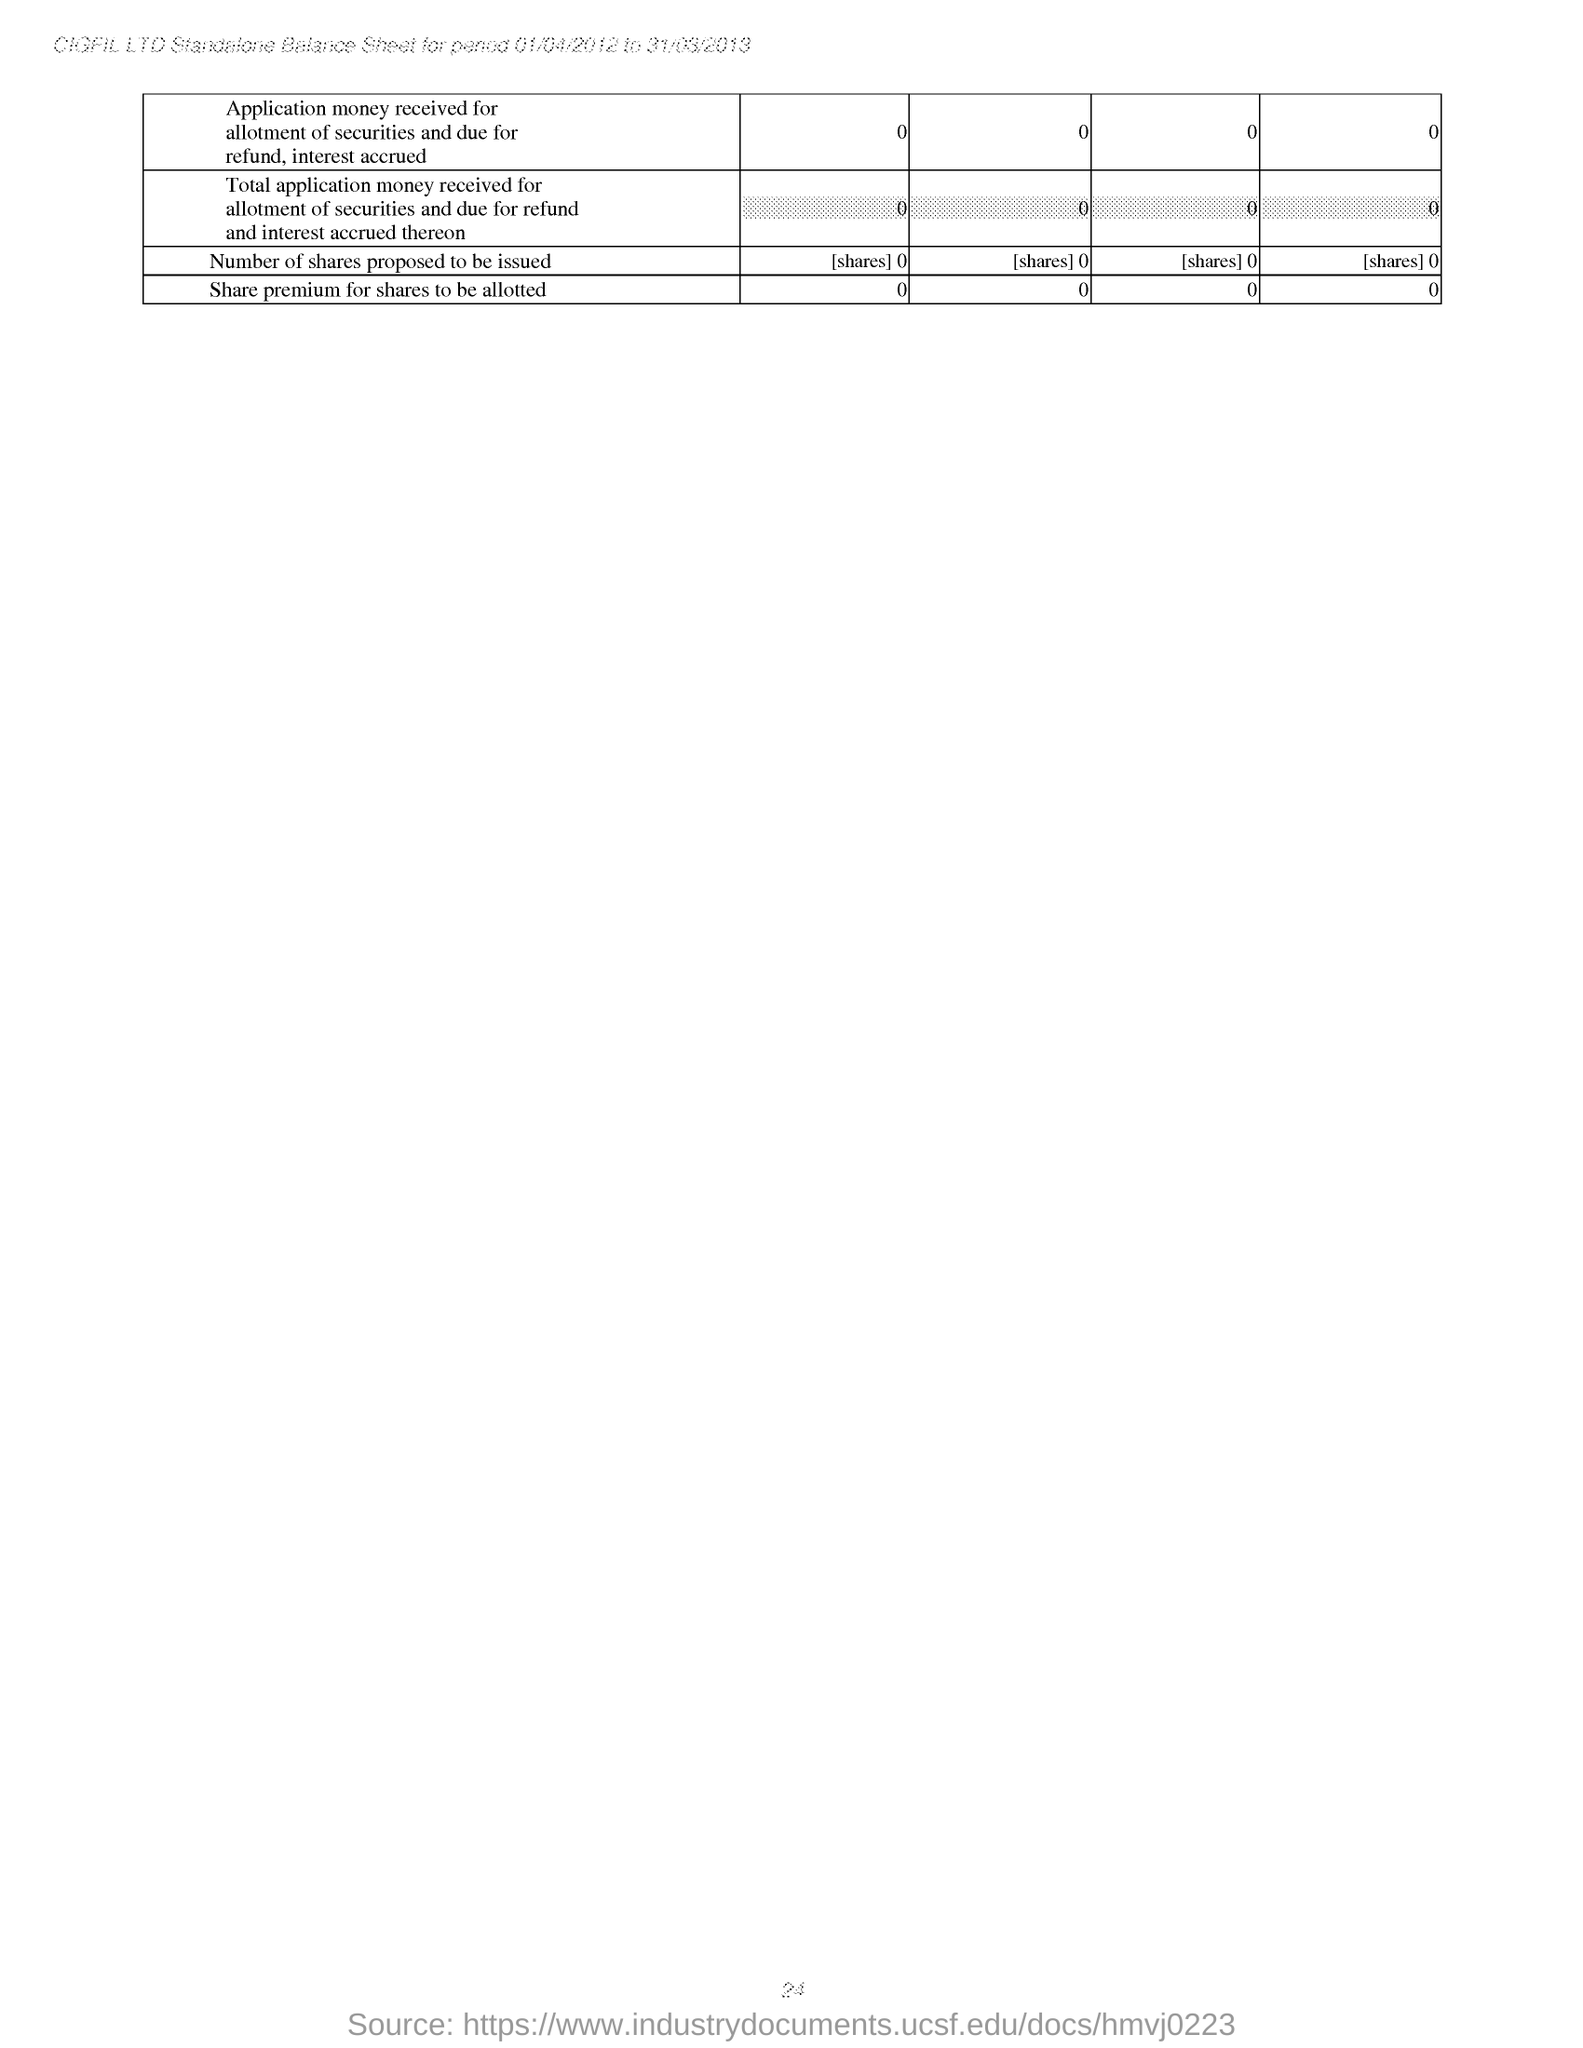Give some essential details in this illustration. The Standalone Balance Sheet mentioned in the header of the document is that of the period 01/04/2012 to 31/03/2013. The company named CIGFIL LTD. is mentioned in the header. 